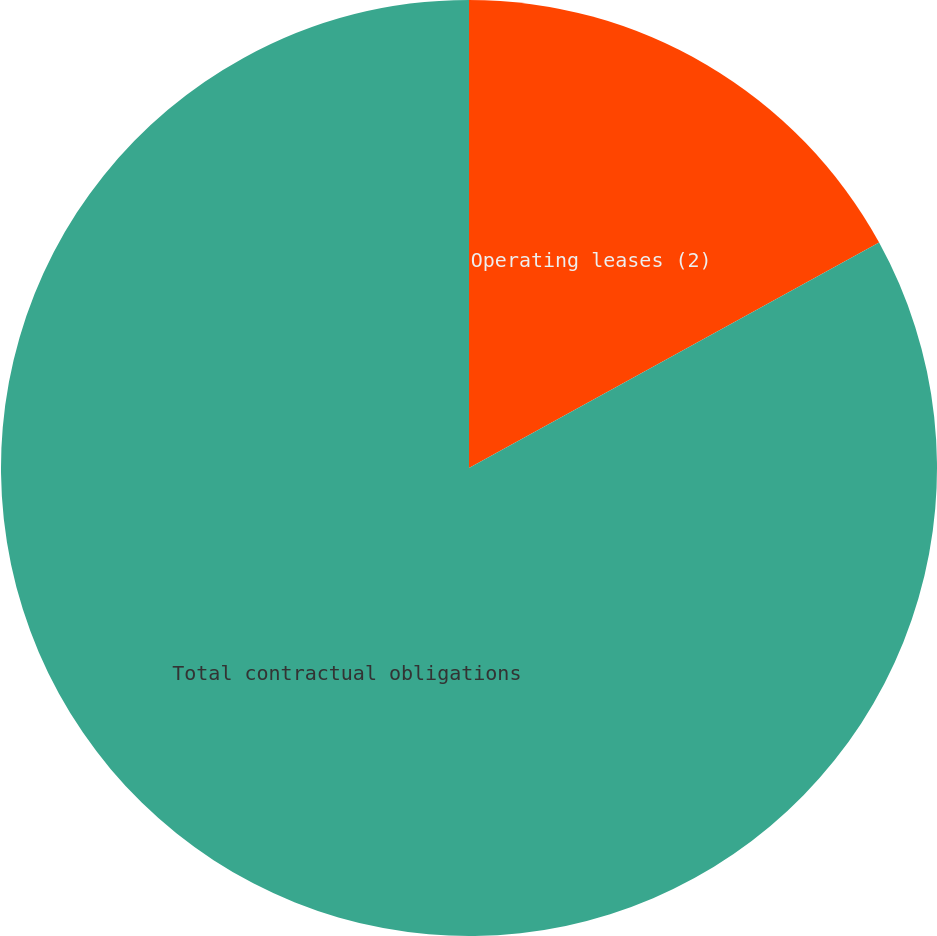<chart> <loc_0><loc_0><loc_500><loc_500><pie_chart><fcel>Operating leases (2)<fcel>Total contractual obligations<nl><fcel>17.0%<fcel>83.0%<nl></chart> 